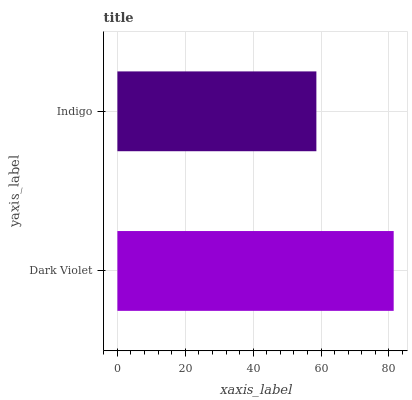Is Indigo the minimum?
Answer yes or no. Yes. Is Dark Violet the maximum?
Answer yes or no. Yes. Is Indigo the maximum?
Answer yes or no. No. Is Dark Violet greater than Indigo?
Answer yes or no. Yes. Is Indigo less than Dark Violet?
Answer yes or no. Yes. Is Indigo greater than Dark Violet?
Answer yes or no. No. Is Dark Violet less than Indigo?
Answer yes or no. No. Is Dark Violet the high median?
Answer yes or no. Yes. Is Indigo the low median?
Answer yes or no. Yes. Is Indigo the high median?
Answer yes or no. No. Is Dark Violet the low median?
Answer yes or no. No. 